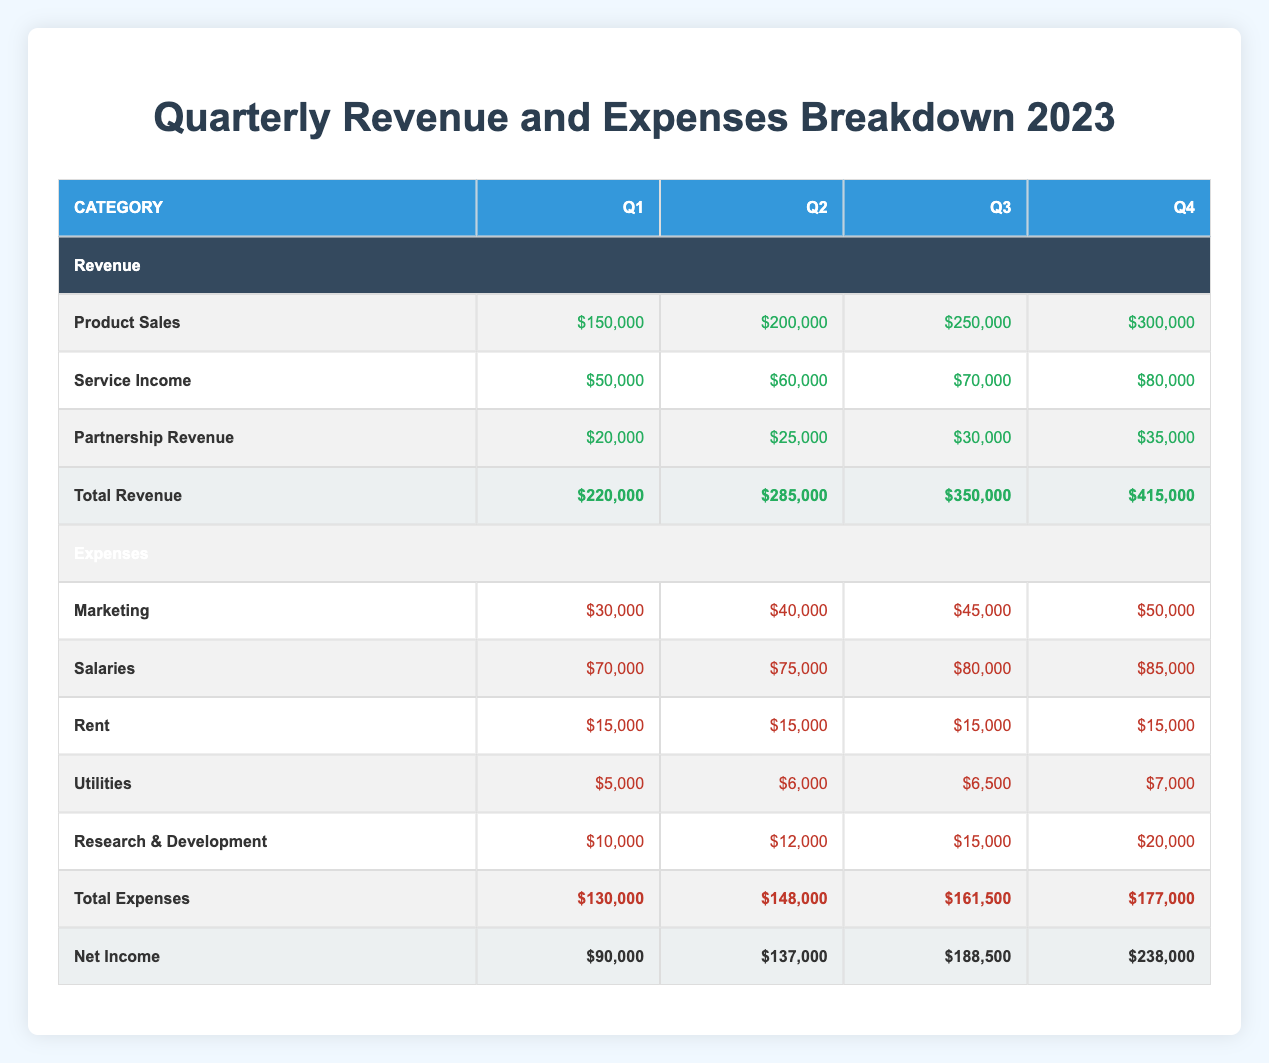What was the total revenue in Q3? The total revenue for Q3 is provided in the table under the 'Total Revenue' row for Q3, which states $350,000.
Answer: 350000 Which quarter had the highest service income? By comparing the 'Service Income' values across the quarters, Q4 has the highest service income at $80,000.
Answer: 80000 What was the increase in net income from Q1 to Q2? Net income for Q1 is $90,000, and for Q2 it is $137,000. The increase is calculated by subtracting Q1's net income from Q2's: 137,000 - 90,000 = 47,000.
Answer: 47000 Did the total expenses exceed the total revenue in any quarter? Checking the 'Total Expenses' and 'Total Revenue' for each quarter shows that in every quarter, revenue exceeds expenses; thus, no quarter had expenses exceeding revenue.
Answer: No What was the average marketing expense over the four quarters? The marketing expenses for the four quarters are $30,000, $40,000, $45,000, and $50,000. Summing these gives 30,000 + 40,000 + 45,000 + 50,000 = 165,000. To find the average, divide by 4 (the number of quarters): 165,000 / 4 = 41,250.
Answer: 41250 What percent of total revenue in Q2 came from product sales? The total revenue for Q2 is $285,000, and product sales account for $200,000. To find the percentage, use the formula (product sales / total revenue) * 100 = (200,000 / 285,000) * 100 ≈ 70.88%.
Answer: Approximately 70.88% What was the rent expense throughout the year? Rent expense remained consistent at $15,000 for each quarter as shown in the table.
Answer: 15000 What is the total revenue for the entire year? Summing the total revenue for each quarter: $220,000 (Q1) + $285,000 (Q2) + $350,000 (Q3) + $415,000 (Q4) = $1,270,000 for the year.
Answer: 1270000 Which quarter saw the highest increase in total revenue compared to the previous quarter? Between the quarters, Q2's revenue increased from Q1 by $65,000 (285,000 - 220,000), Q3 from Q2 by $65,000 (350,000 - 285,000), and Q4 from Q3 by $65,000 (415,000 - 350,000). The increases are the same for Q2, Q3, and Q4.
Answer: Q2, Q3, and Q4 all had an increase of 65000 